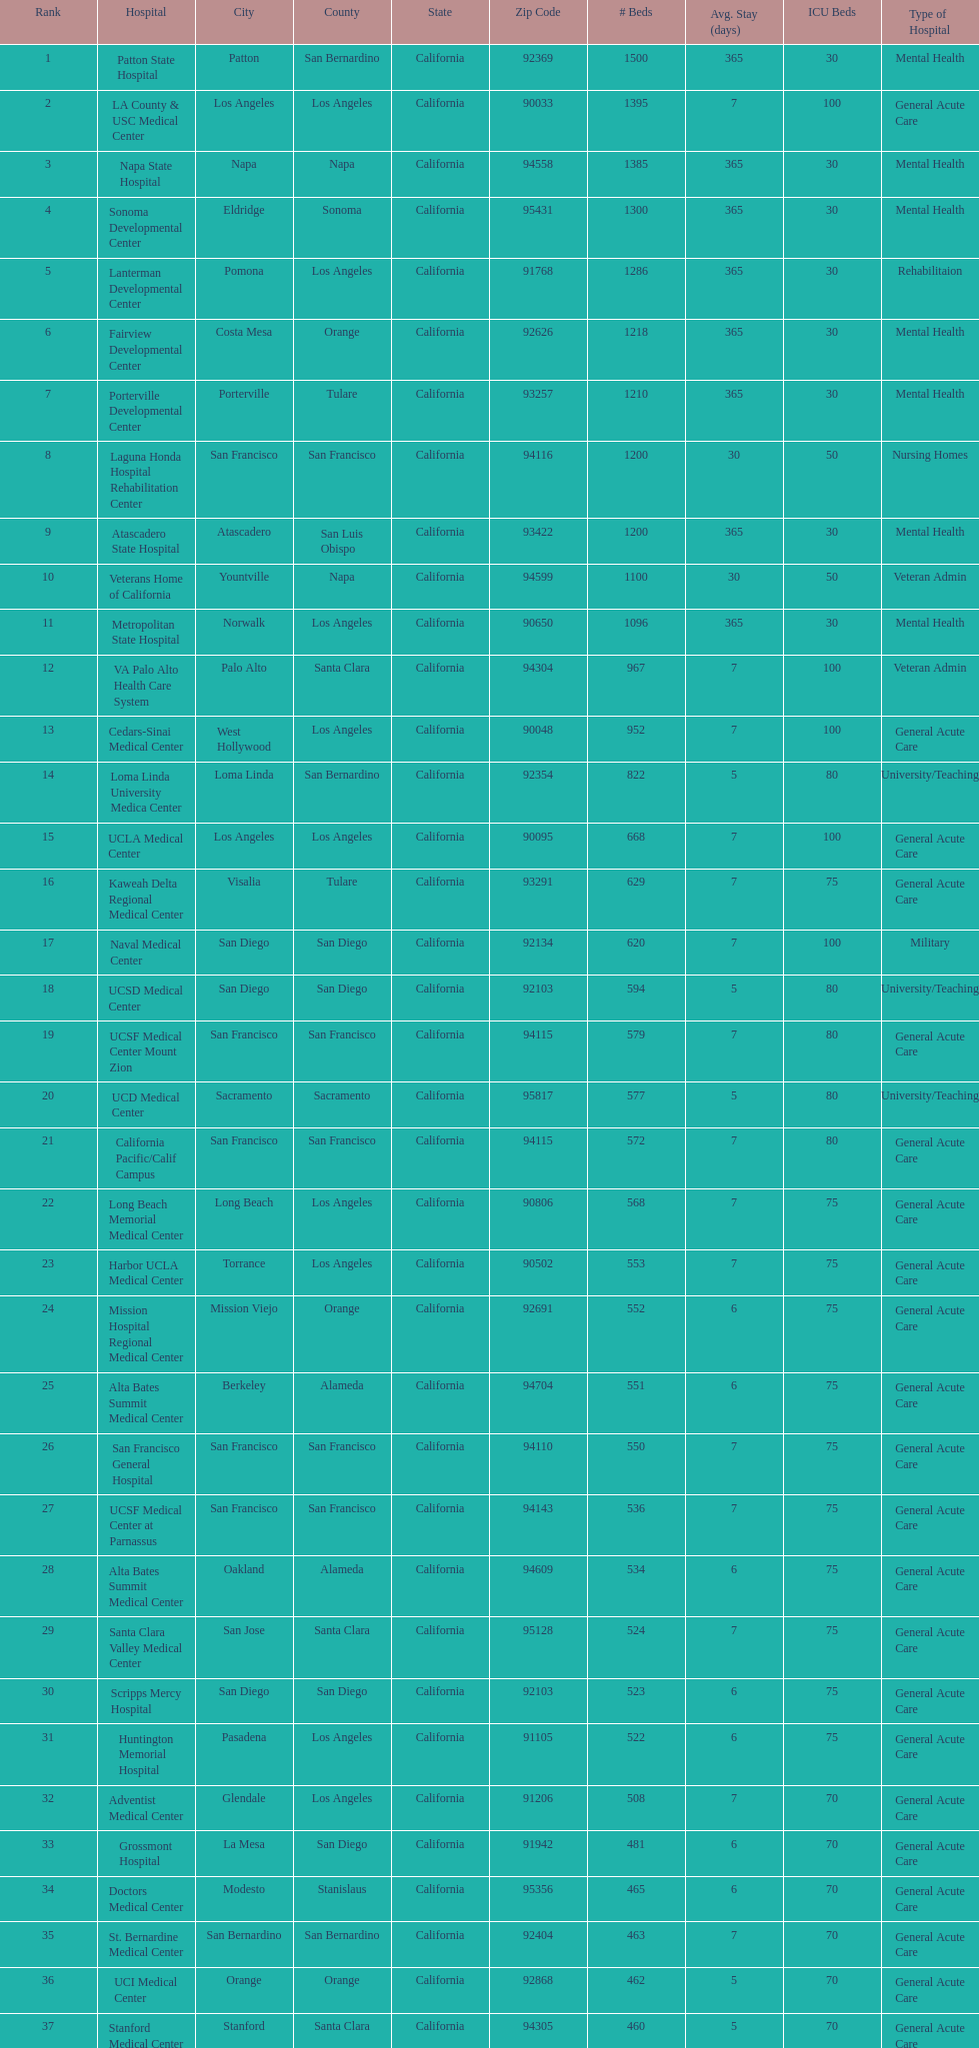How much larger (in number of beds) was the largest hospital in california than the 50th largest? 1071. 